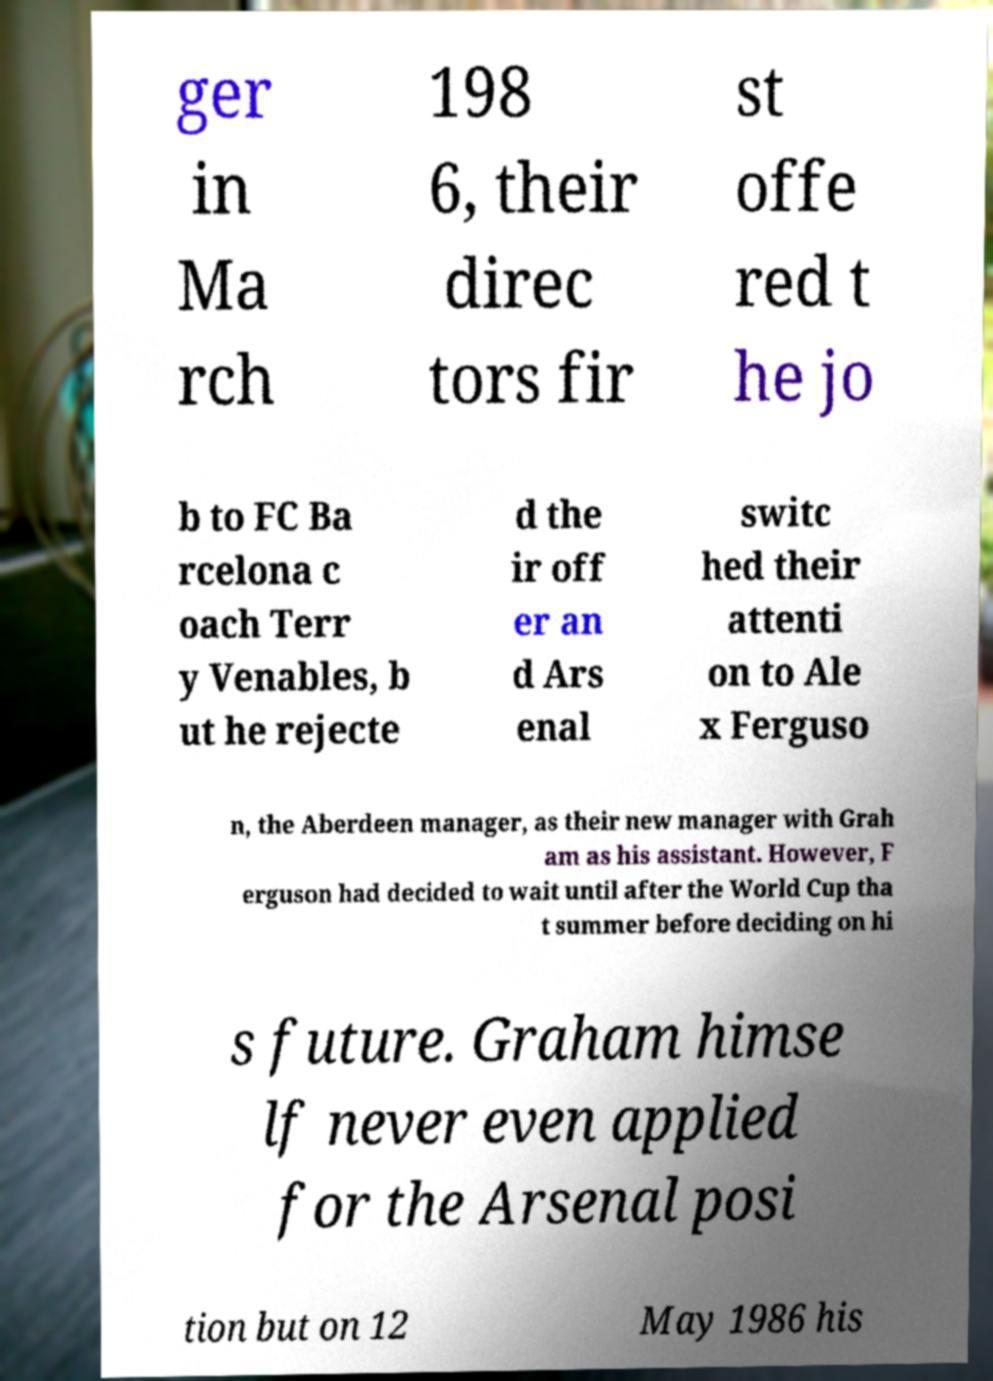What messages or text are displayed in this image? I need them in a readable, typed format. ger in Ma rch 198 6, their direc tors fir st offe red t he jo b to FC Ba rcelona c oach Terr y Venables, b ut he rejecte d the ir off er an d Ars enal switc hed their attenti on to Ale x Ferguso n, the Aberdeen manager, as their new manager with Grah am as his assistant. However, F erguson had decided to wait until after the World Cup tha t summer before deciding on hi s future. Graham himse lf never even applied for the Arsenal posi tion but on 12 May 1986 his 